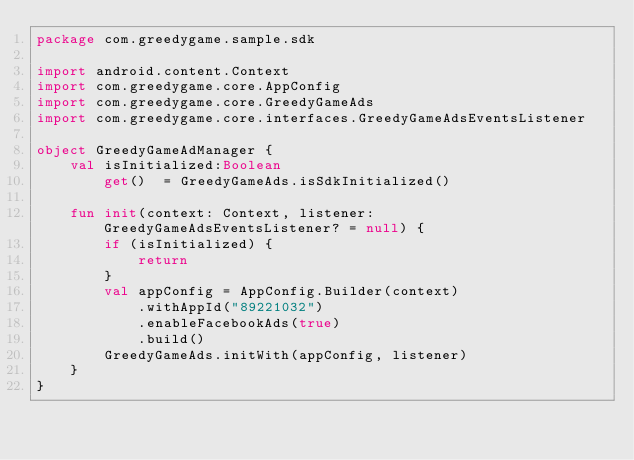<code> <loc_0><loc_0><loc_500><loc_500><_Kotlin_>package com.greedygame.sample.sdk

import android.content.Context
import com.greedygame.core.AppConfig
import com.greedygame.core.GreedyGameAds
import com.greedygame.core.interfaces.GreedyGameAdsEventsListener

object GreedyGameAdManager {
    val isInitialized:Boolean
        get()  = GreedyGameAds.isSdkInitialized()

    fun init(context: Context, listener: GreedyGameAdsEventsListener? = null) {
        if (isInitialized) {
            return
        }
        val appConfig = AppConfig.Builder(context)
            .withAppId("89221032")
            .enableFacebookAds(true)
            .build()
        GreedyGameAds.initWith(appConfig, listener)
    }
}</code> 